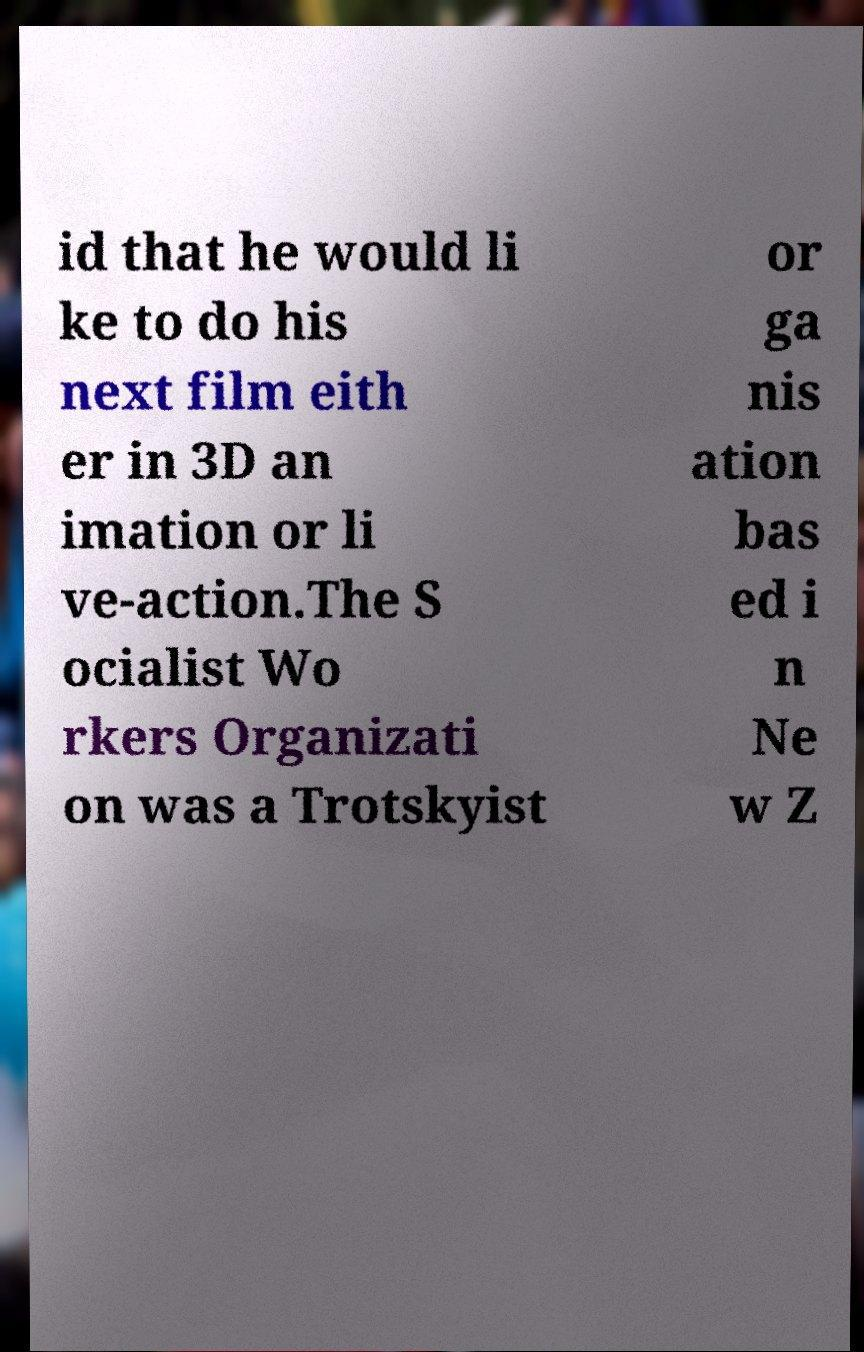There's text embedded in this image that I need extracted. Can you transcribe it verbatim? id that he would li ke to do his next film eith er in 3D an imation or li ve-action.The S ocialist Wo rkers Organizati on was a Trotskyist or ga nis ation bas ed i n Ne w Z 